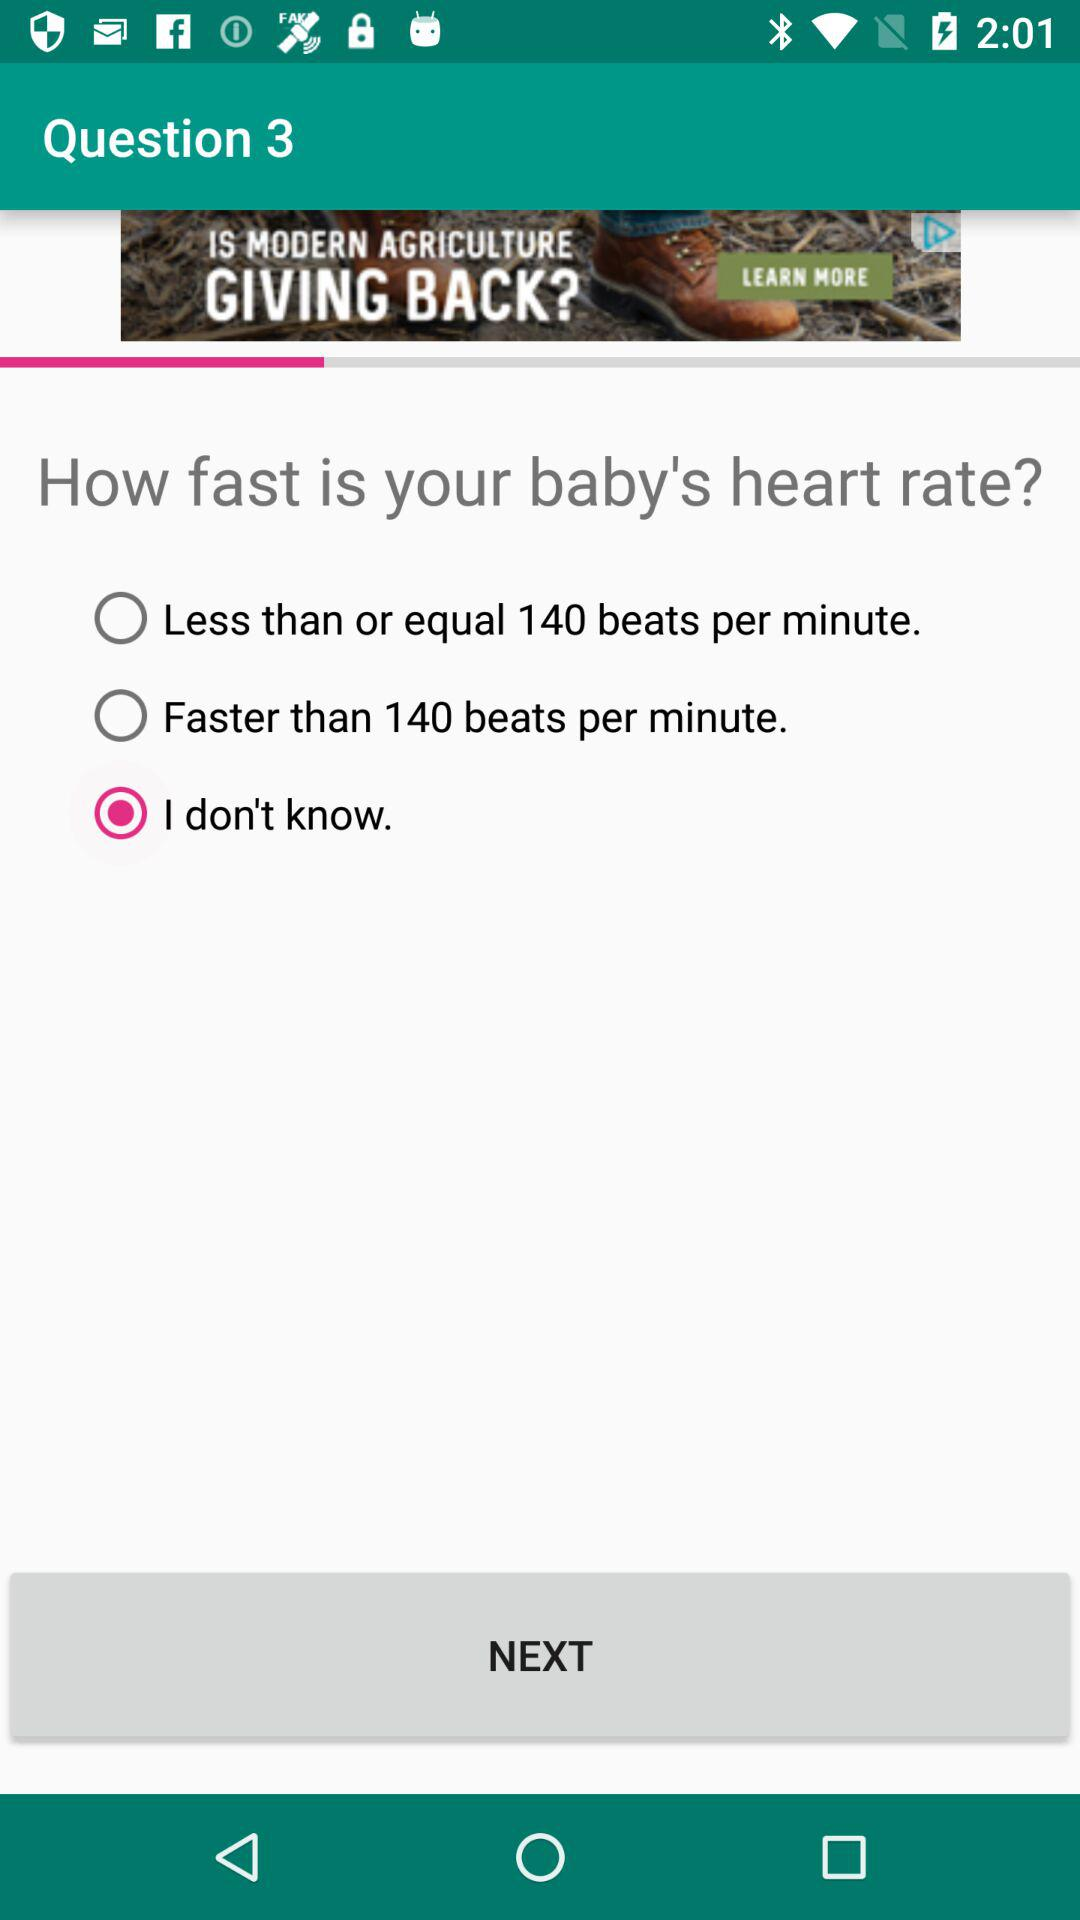Which option is selected? The selected option is "I don't know". 